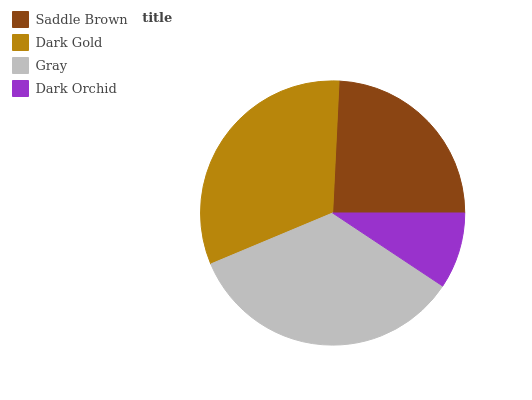Is Dark Orchid the minimum?
Answer yes or no. Yes. Is Gray the maximum?
Answer yes or no. Yes. Is Dark Gold the minimum?
Answer yes or no. No. Is Dark Gold the maximum?
Answer yes or no. No. Is Dark Gold greater than Saddle Brown?
Answer yes or no. Yes. Is Saddle Brown less than Dark Gold?
Answer yes or no. Yes. Is Saddle Brown greater than Dark Gold?
Answer yes or no. No. Is Dark Gold less than Saddle Brown?
Answer yes or no. No. Is Dark Gold the high median?
Answer yes or no. Yes. Is Saddle Brown the low median?
Answer yes or no. Yes. Is Gray the high median?
Answer yes or no. No. Is Dark Orchid the low median?
Answer yes or no. No. 